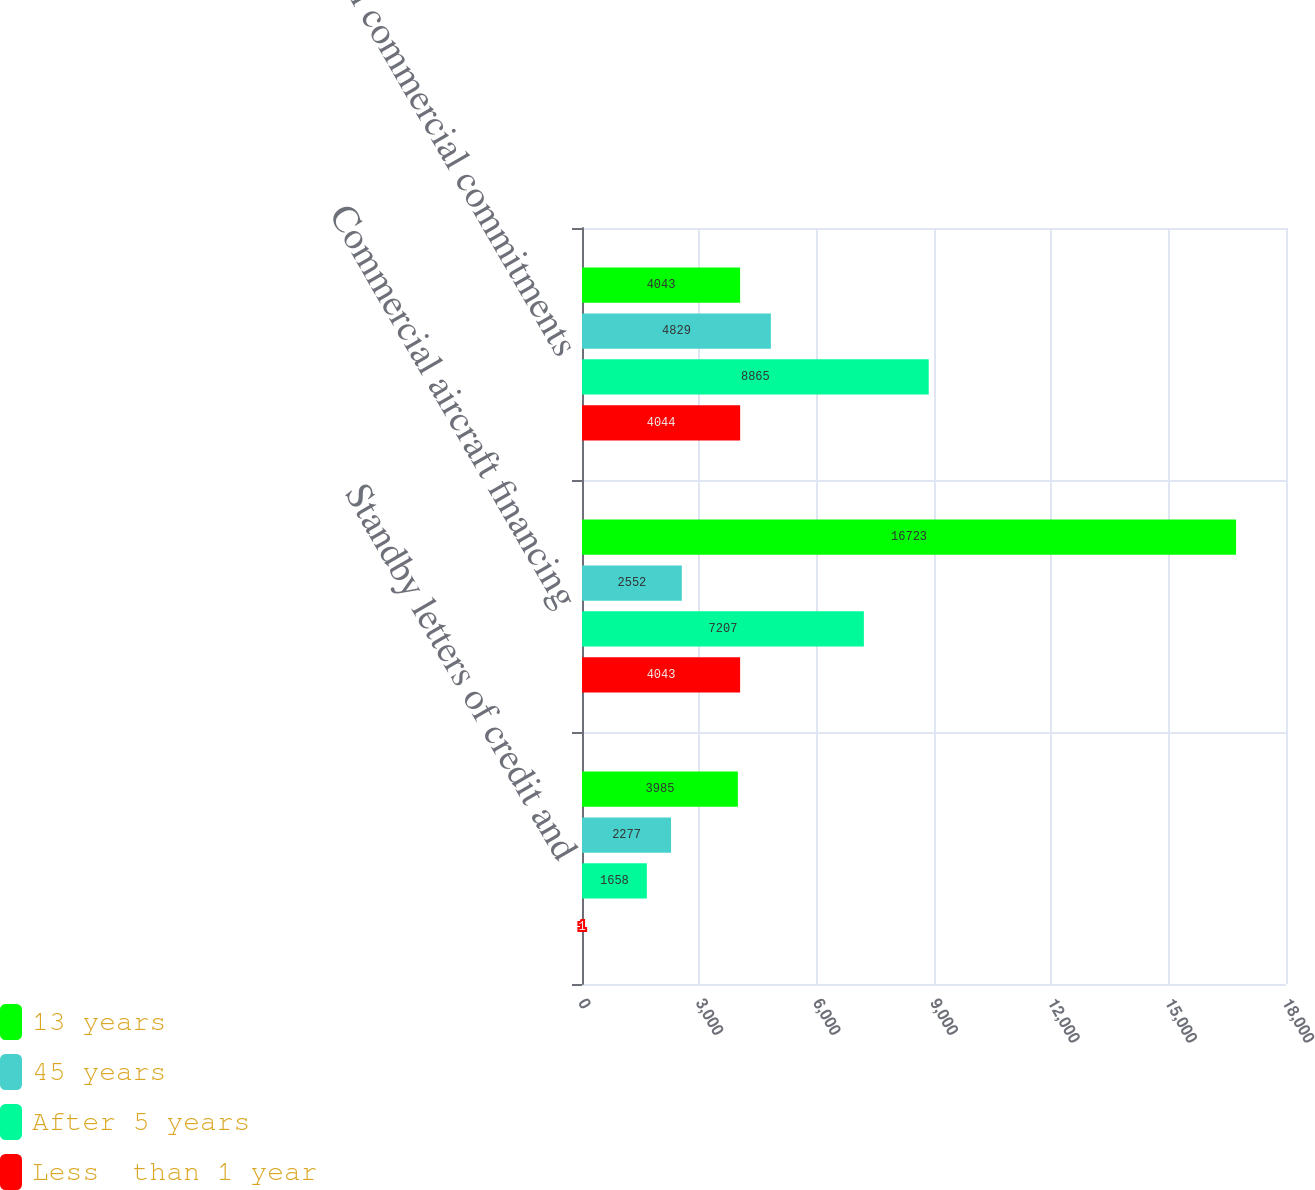Convert chart. <chart><loc_0><loc_0><loc_500><loc_500><stacked_bar_chart><ecel><fcel>Standby letters of credit and<fcel>Commercial aircraft financing<fcel>Total commercial commitments<nl><fcel>13 years<fcel>3985<fcel>16723<fcel>4043<nl><fcel>45 years<fcel>2277<fcel>2552<fcel>4829<nl><fcel>After 5 years<fcel>1658<fcel>7207<fcel>8865<nl><fcel>Less  than 1 year<fcel>1<fcel>4043<fcel>4044<nl></chart> 